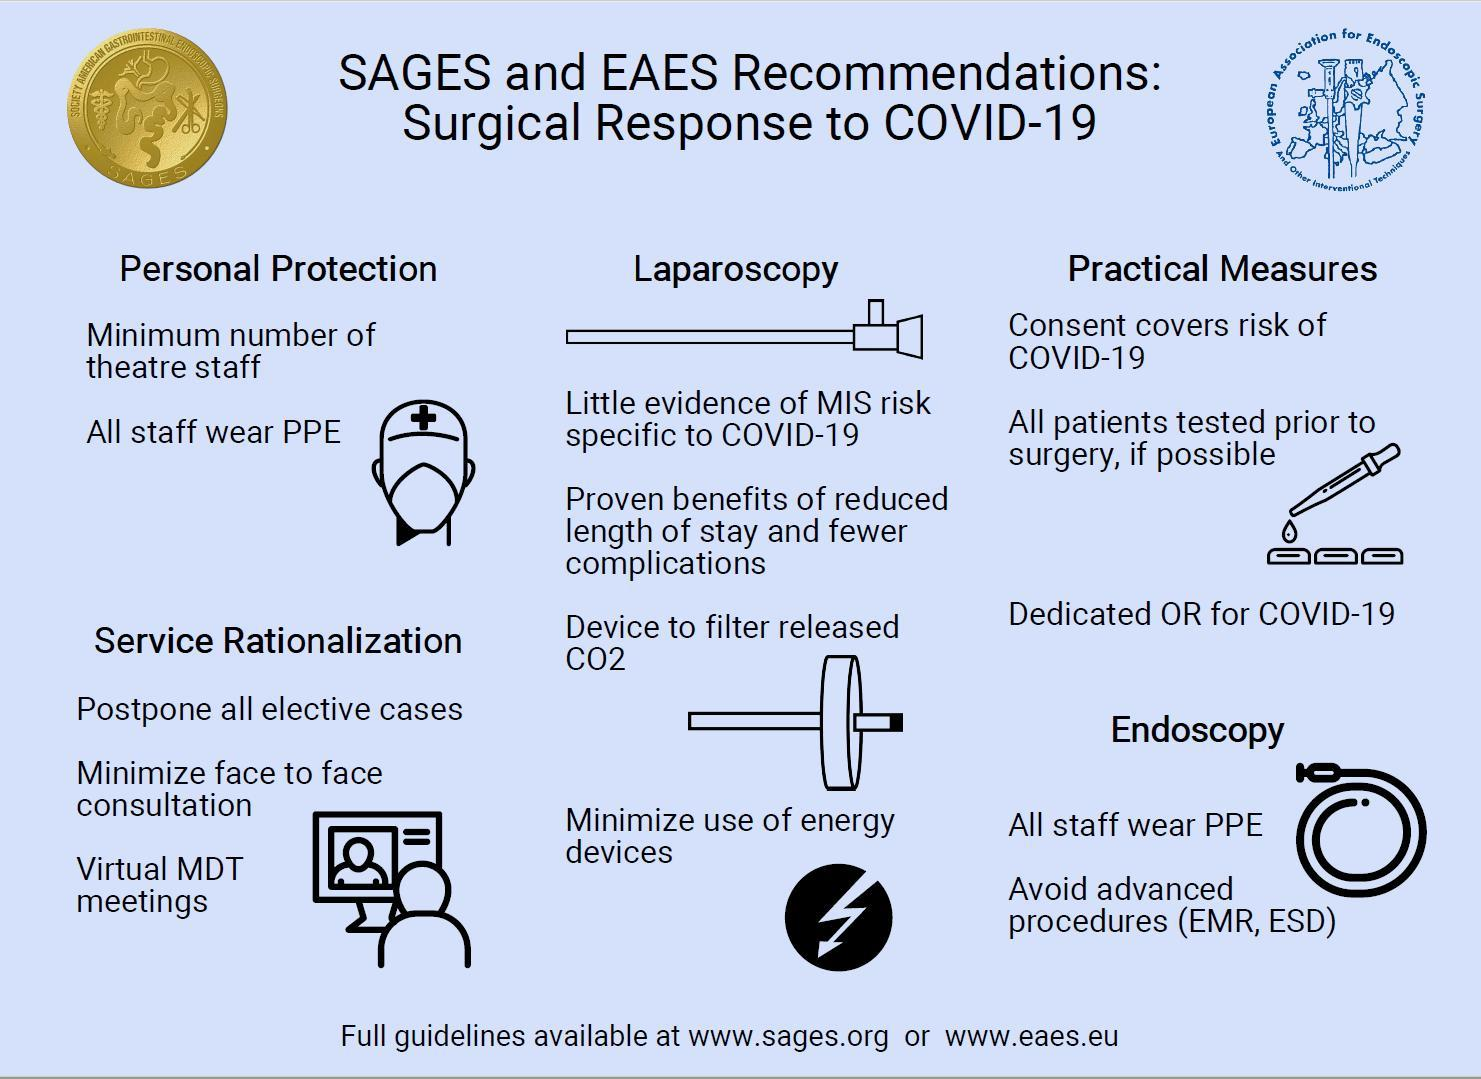What is the third recommendation under practical measures?
Answer the question with a short phrase. Dedicated OR for Covid-19 What is the first recommendation listed under service rationalization? Postpone all elective cases In which procedure should use of energy devices be minimized? Laparoscopy Virtual MDT meetings to be conducted as part of what measure? Service rationalization 